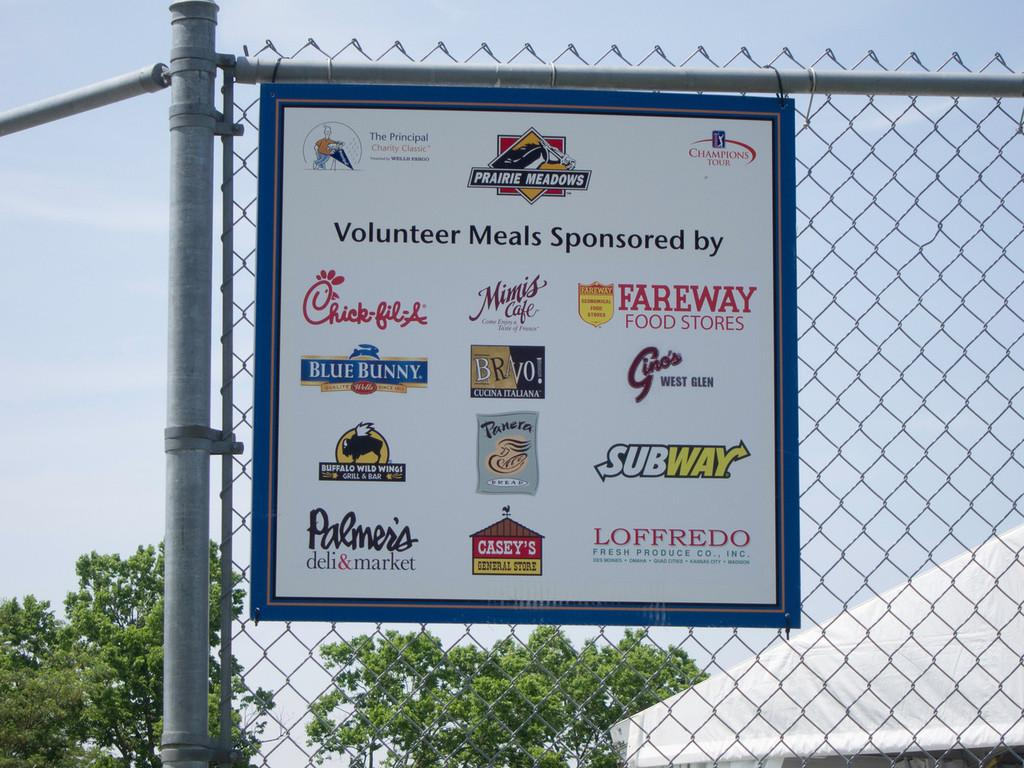<image>
Give a short and clear explanation of the subsequent image. a blue board with signs for companys like Subway and Chick-Fil-A on it 